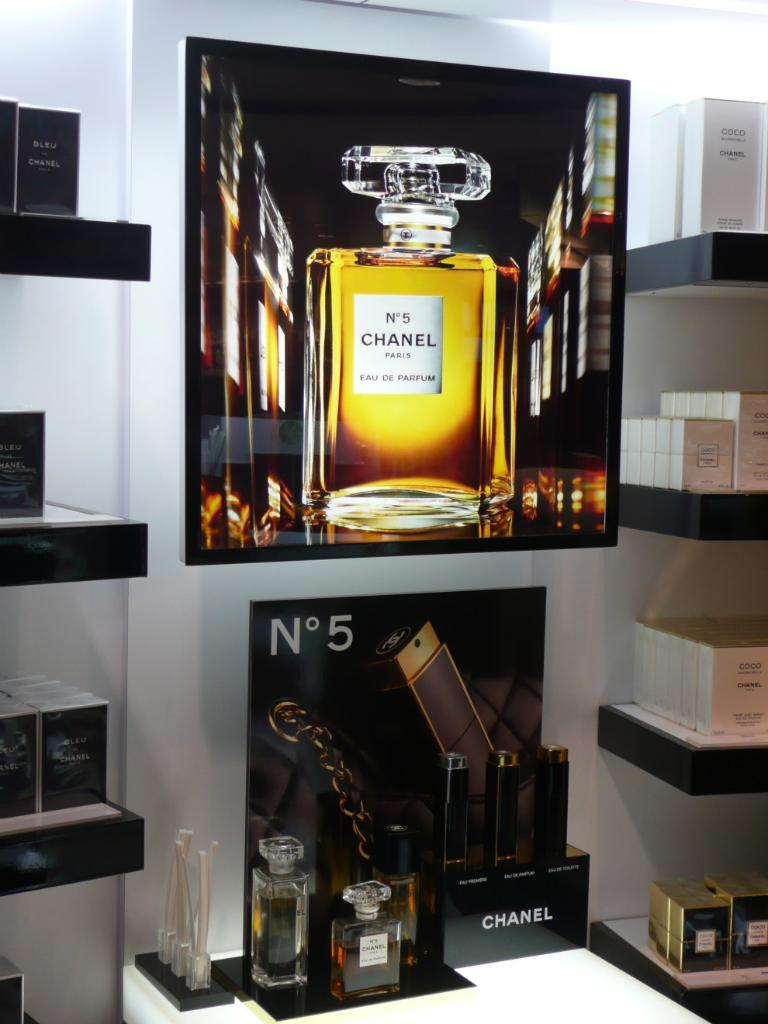Provide a one-sentence caption for the provided image. A perfume display of Channel No. 5 and also shelves of various Channel perfumes. 